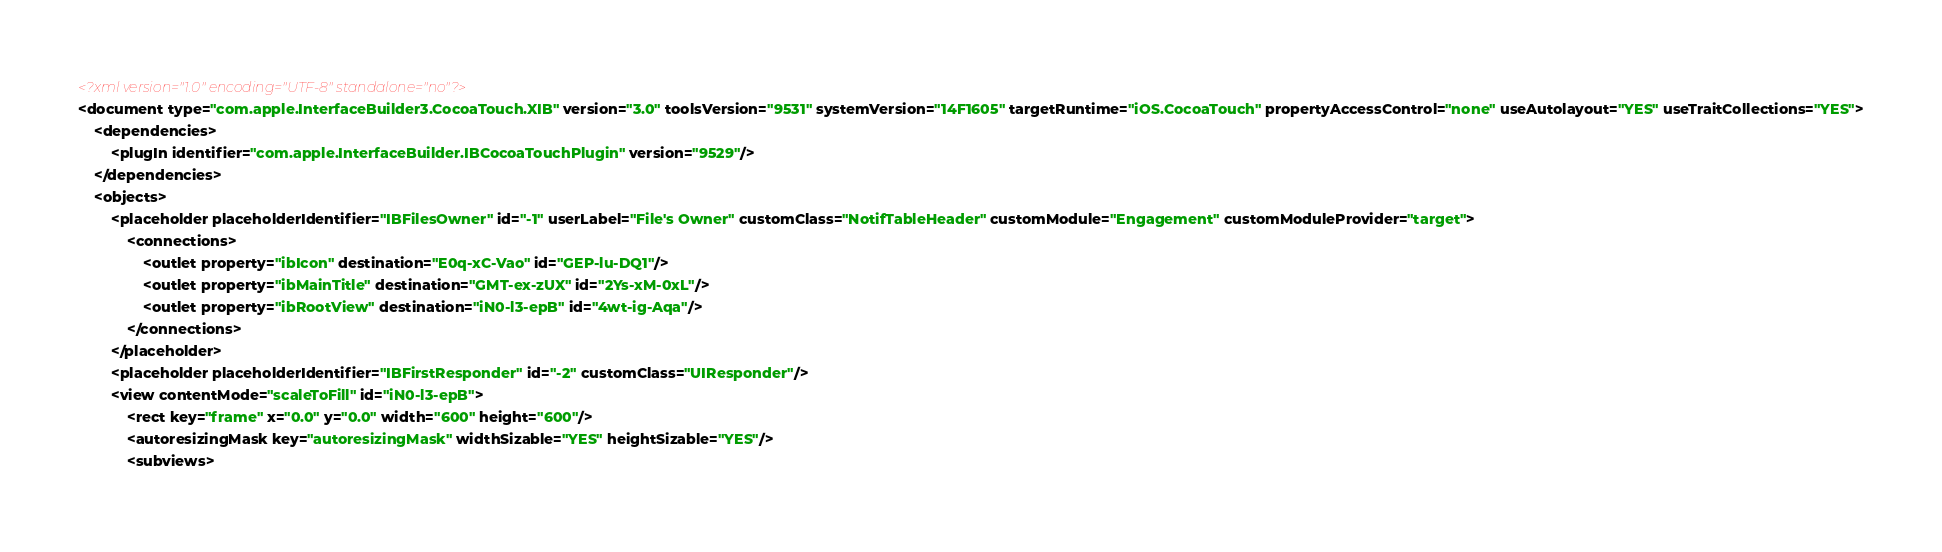<code> <loc_0><loc_0><loc_500><loc_500><_XML_><?xml version="1.0" encoding="UTF-8" standalone="no"?>
<document type="com.apple.InterfaceBuilder3.CocoaTouch.XIB" version="3.0" toolsVersion="9531" systemVersion="14F1605" targetRuntime="iOS.CocoaTouch" propertyAccessControl="none" useAutolayout="YES" useTraitCollections="YES">
    <dependencies>
        <plugIn identifier="com.apple.InterfaceBuilder.IBCocoaTouchPlugin" version="9529"/>
    </dependencies>
    <objects>
        <placeholder placeholderIdentifier="IBFilesOwner" id="-1" userLabel="File's Owner" customClass="NotifTableHeader" customModule="Engagement" customModuleProvider="target">
            <connections>
                <outlet property="ibIcon" destination="E0q-xC-Vao" id="GEP-lu-DQ1"/>
                <outlet property="ibMainTitle" destination="GMT-ex-zUX" id="2Ys-xM-0xL"/>
                <outlet property="ibRootView" destination="iN0-l3-epB" id="4wt-ig-Aqa"/>
            </connections>
        </placeholder>
        <placeholder placeholderIdentifier="IBFirstResponder" id="-2" customClass="UIResponder"/>
        <view contentMode="scaleToFill" id="iN0-l3-epB">
            <rect key="frame" x="0.0" y="0.0" width="600" height="600"/>
            <autoresizingMask key="autoresizingMask" widthSizable="YES" heightSizable="YES"/>
            <subviews></code> 